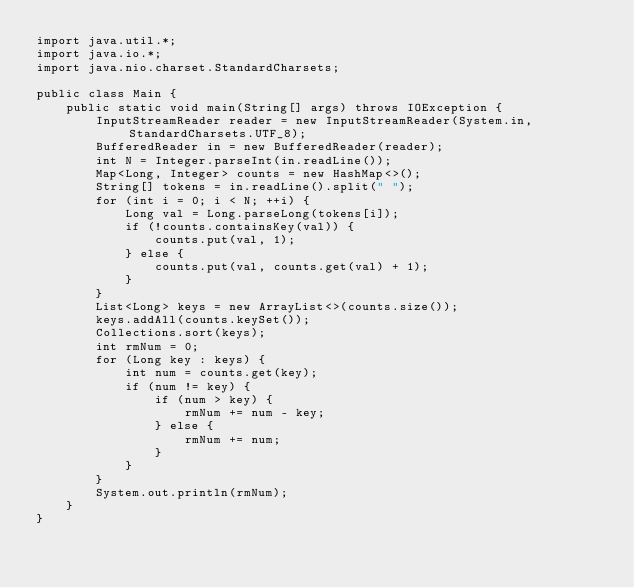Convert code to text. <code><loc_0><loc_0><loc_500><loc_500><_Java_>import java.util.*;
import java.io.*;
import java.nio.charset.StandardCharsets;

public class Main {
	public static void main(String[] args) throws IOException {
		InputStreamReader reader = new InputStreamReader(System.in, StandardCharsets.UTF_8);
		BufferedReader in = new BufferedReader(reader);
		int N = Integer.parseInt(in.readLine());
		Map<Long, Integer> counts = new HashMap<>();
		String[] tokens = in.readLine().split(" ");
		for (int i = 0; i < N; ++i) {
			Long val = Long.parseLong(tokens[i]);
			if (!counts.containsKey(val)) {
				counts.put(val, 1);
			} else {
				counts.put(val, counts.get(val) + 1);
			}
		}
		List<Long> keys = new ArrayList<>(counts.size());
		keys.addAll(counts.keySet());
		Collections.sort(keys);
		int rmNum = 0;
		for (Long key : keys) {
			int num = counts.get(key);
			if (num != key) {
				if (num > key) {
					rmNum += num - key;
				} else {
					rmNum += num;
				}
			}
		}
		System.out.println(rmNum);
	}
}
</code> 